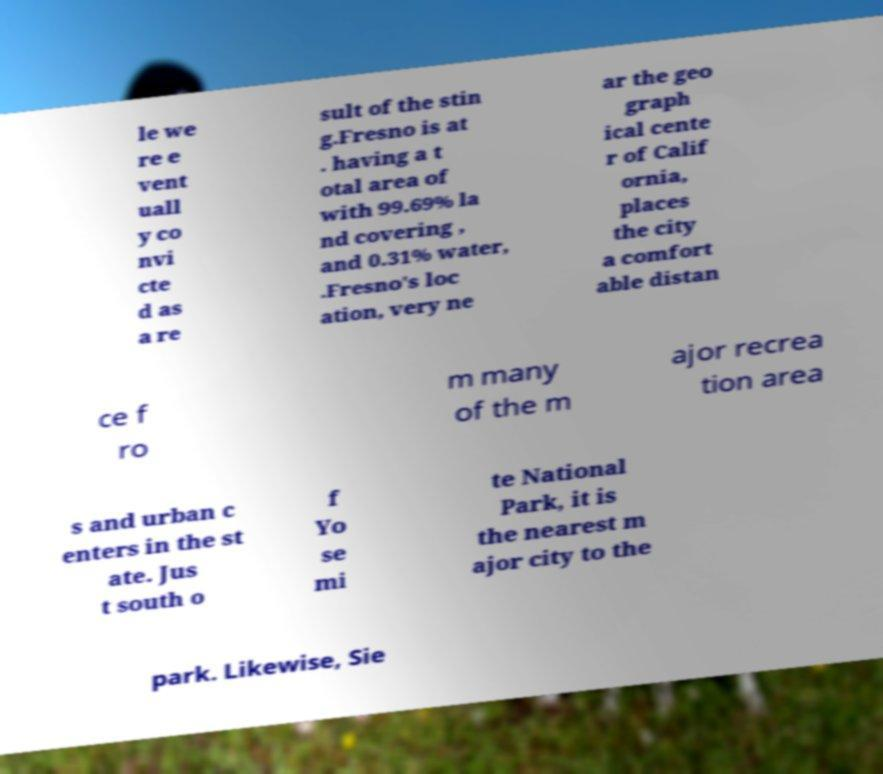Could you assist in decoding the text presented in this image and type it out clearly? le we re e vent uall y co nvi cte d as a re sult of the stin g.Fresno is at . having a t otal area of with 99.69% la nd covering , and 0.31% water, .Fresno's loc ation, very ne ar the geo graph ical cente r of Calif ornia, places the city a comfort able distan ce f ro m many of the m ajor recrea tion area s and urban c enters in the st ate. Jus t south o f Yo se mi te National Park, it is the nearest m ajor city to the park. Likewise, Sie 